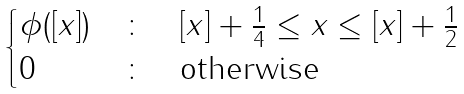<formula> <loc_0><loc_0><loc_500><loc_500>\begin{cases} \phi ( [ x ] ) & \colon \quad [ x ] + \frac { 1 } { 4 } \leq x \leq [ x ] + \frac { 1 } { 2 } \\ 0 & \colon \quad \text {otherwise} \end{cases}</formula> 